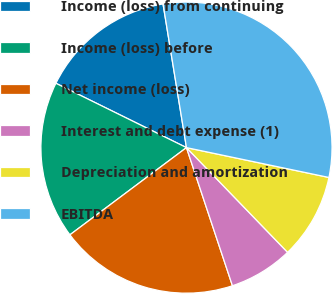<chart> <loc_0><loc_0><loc_500><loc_500><pie_chart><fcel>Income (loss) from continuing<fcel>Income (loss) before<fcel>Net income (loss)<fcel>Interest and debt expense (1)<fcel>Depreciation and amortization<fcel>EBITDA<nl><fcel>15.14%<fcel>17.51%<fcel>19.89%<fcel>7.11%<fcel>9.49%<fcel>30.86%<nl></chart> 